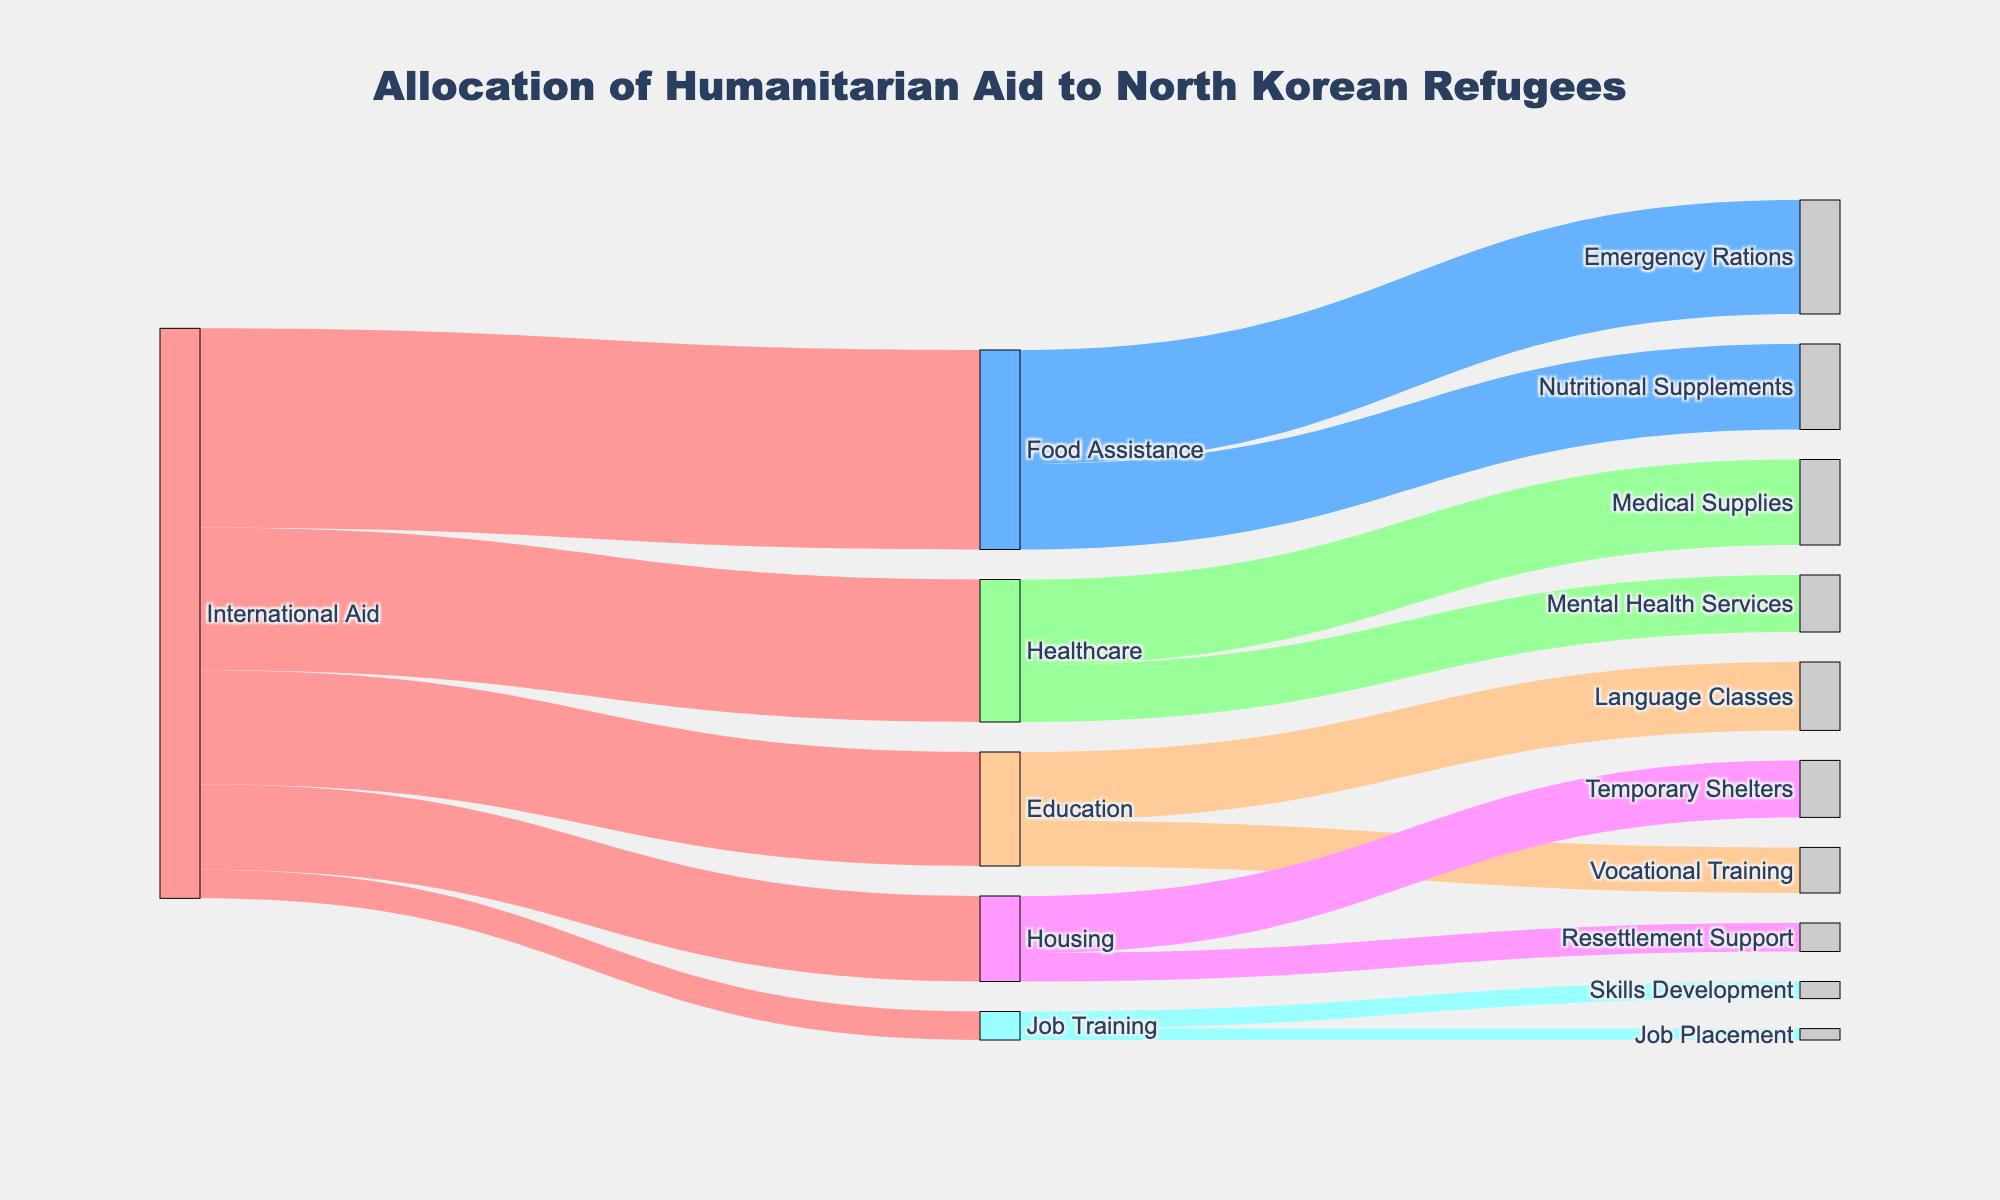What is the title of the Sankey diagram? The title of the Sankey diagram is usually displayed at the top of the figure in bold text. By looking at its position and style, the title is "Allocation of Humanitarian Aid to North Korean Refugees."
Answer: Allocation of Humanitarian Aid to North Korean Refugees How much aid is allocated to Food Assistance? The value for Food Assistance can be identified by looking at where the flow from International Aid to Food Assistance is represented. The value associated here is 35.
Answer: 35 Which sector receives the least amount of Main International Aid? By comparing the initial values split from the International Aid node, Job Training shows the smallest value of 5.
Answer: Job Training How much aid in total goes from Food Assistance to both of its subcategories? The values from Food Assistance to Emergency Rations and Nutritional Supplements are 20 and 15 respectively. Adding these values gives 20 + 15 = 35.
Answer: 35 Which subcategory under Healthcare receives more aid? Comparing the flows coming from Healthcare to its subcategories, Medical Supplies (15) receives more aid than Mental Health Services (10).
Answer: Medical Supplies What's the total aid allocated to Housing and Job Training combined? Summing the values of Housing (15) and Job Training (5) from the International Aid node gives 15 + 5 = 20.
Answer: 20 What is the total amount of aid allocated to all sectors combined? Adding up all the values from International Aid (35 Food Assistance + 25 Healthcare + 20 Education + 15 Housing + 5 Job Training) gives a total of 100.
Answer: 100 Which sector under Education receives less aid? From the values flowing from Education, Language Classes receive 12 while Vocational Training receives 8, so Vocational Training receives less aid.
Answer: Vocational Training Is there more aid directed towards Resettlement Support or Skills Development? The amount of aid is 5 for Resettlement Support and 3 for Skills Development, thus more aid is directed towards Resettlement Support.
Answer: Resettlement Support Which sector receives the largest aid chunk under the broader category of Food Assistance? Comparing Emergency Rations (20) and Nutritional Supplements (15) under Food Assistance, Emergency Rations receive the largest chunk.
Answer: Emergency Rations 